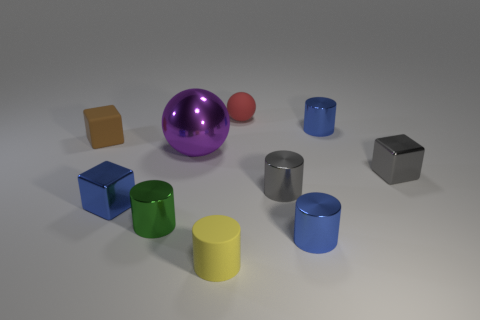If I were to touch the closest blue cylinder, how would it feel? If you were to touch the blue cylinder closest to your viewpoint, it would likely feel smooth and cool to the touch. The reflective surface suggests a material such as painted metal or plastic, which is typically sleek and has a certain temperature coolness when not warmed by ambient conditions. 